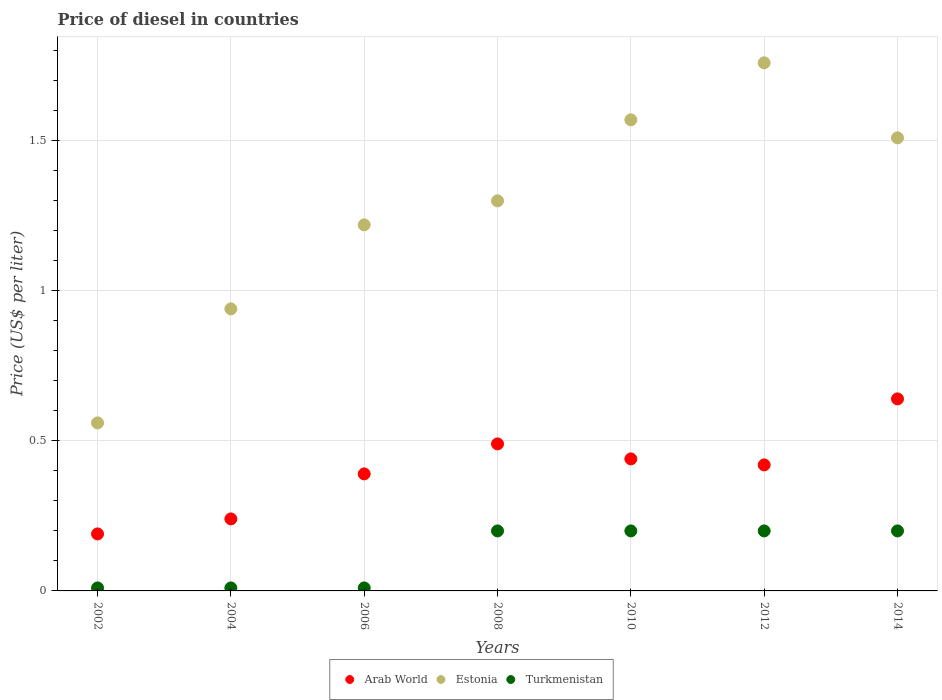Is the number of dotlines equal to the number of legend labels?
Your answer should be very brief. Yes. Across all years, what is the maximum price of diesel in Arab World?
Keep it short and to the point. 0.64. Across all years, what is the minimum price of diesel in Estonia?
Ensure brevity in your answer.  0.56. In which year was the price of diesel in Estonia maximum?
Give a very brief answer. 2012. What is the total price of diesel in Turkmenistan in the graph?
Keep it short and to the point. 0.83. What is the difference between the price of diesel in Estonia in 2004 and that in 2008?
Make the answer very short. -0.36. What is the difference between the price of diesel in Turkmenistan in 2004 and the price of diesel in Arab World in 2014?
Offer a very short reply. -0.63. What is the average price of diesel in Estonia per year?
Your response must be concise. 1.27. In the year 2010, what is the difference between the price of diesel in Estonia and price of diesel in Arab World?
Keep it short and to the point. 1.13. What is the ratio of the price of diesel in Estonia in 2002 to that in 2006?
Your answer should be very brief. 0.46. Is the price of diesel in Arab World in 2008 less than that in 2010?
Provide a short and direct response. No. Is the difference between the price of diesel in Estonia in 2006 and 2010 greater than the difference between the price of diesel in Arab World in 2006 and 2010?
Provide a succinct answer. No. What is the difference between the highest and the second highest price of diesel in Arab World?
Keep it short and to the point. 0.15. What is the difference between the highest and the lowest price of diesel in Turkmenistan?
Ensure brevity in your answer.  0.19. In how many years, is the price of diesel in Arab World greater than the average price of diesel in Arab World taken over all years?
Offer a very short reply. 4. Is the sum of the price of diesel in Turkmenistan in 2012 and 2014 greater than the maximum price of diesel in Estonia across all years?
Provide a succinct answer. No. Is it the case that in every year, the sum of the price of diesel in Arab World and price of diesel in Turkmenistan  is greater than the price of diesel in Estonia?
Your answer should be compact. No. Is the price of diesel in Estonia strictly less than the price of diesel in Arab World over the years?
Offer a very short reply. No. How many dotlines are there?
Offer a very short reply. 3. Does the graph contain any zero values?
Provide a succinct answer. No. What is the title of the graph?
Give a very brief answer. Price of diesel in countries. What is the label or title of the X-axis?
Your answer should be very brief. Years. What is the label or title of the Y-axis?
Provide a succinct answer. Price (US$ per liter). What is the Price (US$ per liter) of Arab World in 2002?
Make the answer very short. 0.19. What is the Price (US$ per liter) in Estonia in 2002?
Provide a short and direct response. 0.56. What is the Price (US$ per liter) in Arab World in 2004?
Provide a succinct answer. 0.24. What is the Price (US$ per liter) in Arab World in 2006?
Offer a very short reply. 0.39. What is the Price (US$ per liter) of Estonia in 2006?
Make the answer very short. 1.22. What is the Price (US$ per liter) of Turkmenistan in 2006?
Ensure brevity in your answer.  0.01. What is the Price (US$ per liter) in Arab World in 2008?
Provide a succinct answer. 0.49. What is the Price (US$ per liter) in Estonia in 2008?
Offer a terse response. 1.3. What is the Price (US$ per liter) in Arab World in 2010?
Your answer should be very brief. 0.44. What is the Price (US$ per liter) of Estonia in 2010?
Your answer should be compact. 1.57. What is the Price (US$ per liter) in Arab World in 2012?
Give a very brief answer. 0.42. What is the Price (US$ per liter) in Estonia in 2012?
Make the answer very short. 1.76. What is the Price (US$ per liter) of Arab World in 2014?
Provide a succinct answer. 0.64. What is the Price (US$ per liter) in Estonia in 2014?
Keep it short and to the point. 1.51. What is the Price (US$ per liter) in Turkmenistan in 2014?
Make the answer very short. 0.2. Across all years, what is the maximum Price (US$ per liter) in Arab World?
Provide a succinct answer. 0.64. Across all years, what is the maximum Price (US$ per liter) of Estonia?
Offer a very short reply. 1.76. Across all years, what is the minimum Price (US$ per liter) in Arab World?
Offer a terse response. 0.19. Across all years, what is the minimum Price (US$ per liter) of Estonia?
Your answer should be compact. 0.56. What is the total Price (US$ per liter) in Arab World in the graph?
Your response must be concise. 2.81. What is the total Price (US$ per liter) in Estonia in the graph?
Provide a short and direct response. 8.86. What is the total Price (US$ per liter) in Turkmenistan in the graph?
Give a very brief answer. 0.83. What is the difference between the Price (US$ per liter) of Arab World in 2002 and that in 2004?
Keep it short and to the point. -0.05. What is the difference between the Price (US$ per liter) of Estonia in 2002 and that in 2004?
Your response must be concise. -0.38. What is the difference between the Price (US$ per liter) in Estonia in 2002 and that in 2006?
Offer a terse response. -0.66. What is the difference between the Price (US$ per liter) in Turkmenistan in 2002 and that in 2006?
Provide a succinct answer. 0. What is the difference between the Price (US$ per liter) in Arab World in 2002 and that in 2008?
Offer a very short reply. -0.3. What is the difference between the Price (US$ per liter) in Estonia in 2002 and that in 2008?
Your answer should be very brief. -0.74. What is the difference between the Price (US$ per liter) of Turkmenistan in 2002 and that in 2008?
Keep it short and to the point. -0.19. What is the difference between the Price (US$ per liter) of Estonia in 2002 and that in 2010?
Keep it short and to the point. -1.01. What is the difference between the Price (US$ per liter) in Turkmenistan in 2002 and that in 2010?
Keep it short and to the point. -0.19. What is the difference between the Price (US$ per liter) in Arab World in 2002 and that in 2012?
Your answer should be very brief. -0.23. What is the difference between the Price (US$ per liter) of Estonia in 2002 and that in 2012?
Make the answer very short. -1.2. What is the difference between the Price (US$ per liter) of Turkmenistan in 2002 and that in 2012?
Offer a terse response. -0.19. What is the difference between the Price (US$ per liter) of Arab World in 2002 and that in 2014?
Offer a terse response. -0.45. What is the difference between the Price (US$ per liter) in Estonia in 2002 and that in 2014?
Make the answer very short. -0.95. What is the difference between the Price (US$ per liter) in Turkmenistan in 2002 and that in 2014?
Offer a terse response. -0.19. What is the difference between the Price (US$ per liter) of Arab World in 2004 and that in 2006?
Ensure brevity in your answer.  -0.15. What is the difference between the Price (US$ per liter) of Estonia in 2004 and that in 2006?
Make the answer very short. -0.28. What is the difference between the Price (US$ per liter) in Turkmenistan in 2004 and that in 2006?
Your response must be concise. 0. What is the difference between the Price (US$ per liter) in Arab World in 2004 and that in 2008?
Make the answer very short. -0.25. What is the difference between the Price (US$ per liter) in Estonia in 2004 and that in 2008?
Offer a terse response. -0.36. What is the difference between the Price (US$ per liter) of Turkmenistan in 2004 and that in 2008?
Keep it short and to the point. -0.19. What is the difference between the Price (US$ per liter) of Arab World in 2004 and that in 2010?
Your answer should be compact. -0.2. What is the difference between the Price (US$ per liter) of Estonia in 2004 and that in 2010?
Ensure brevity in your answer.  -0.63. What is the difference between the Price (US$ per liter) in Turkmenistan in 2004 and that in 2010?
Make the answer very short. -0.19. What is the difference between the Price (US$ per liter) of Arab World in 2004 and that in 2012?
Offer a very short reply. -0.18. What is the difference between the Price (US$ per liter) of Estonia in 2004 and that in 2012?
Keep it short and to the point. -0.82. What is the difference between the Price (US$ per liter) of Turkmenistan in 2004 and that in 2012?
Provide a short and direct response. -0.19. What is the difference between the Price (US$ per liter) in Arab World in 2004 and that in 2014?
Provide a succinct answer. -0.4. What is the difference between the Price (US$ per liter) in Estonia in 2004 and that in 2014?
Provide a succinct answer. -0.57. What is the difference between the Price (US$ per liter) in Turkmenistan in 2004 and that in 2014?
Give a very brief answer. -0.19. What is the difference between the Price (US$ per liter) in Estonia in 2006 and that in 2008?
Your answer should be very brief. -0.08. What is the difference between the Price (US$ per liter) in Turkmenistan in 2006 and that in 2008?
Give a very brief answer. -0.19. What is the difference between the Price (US$ per liter) in Estonia in 2006 and that in 2010?
Your response must be concise. -0.35. What is the difference between the Price (US$ per liter) of Turkmenistan in 2006 and that in 2010?
Give a very brief answer. -0.19. What is the difference between the Price (US$ per liter) in Arab World in 2006 and that in 2012?
Offer a terse response. -0.03. What is the difference between the Price (US$ per liter) of Estonia in 2006 and that in 2012?
Make the answer very short. -0.54. What is the difference between the Price (US$ per liter) in Turkmenistan in 2006 and that in 2012?
Ensure brevity in your answer.  -0.19. What is the difference between the Price (US$ per liter) in Arab World in 2006 and that in 2014?
Your answer should be compact. -0.25. What is the difference between the Price (US$ per liter) in Estonia in 2006 and that in 2014?
Your answer should be compact. -0.29. What is the difference between the Price (US$ per liter) in Turkmenistan in 2006 and that in 2014?
Your response must be concise. -0.19. What is the difference between the Price (US$ per liter) in Arab World in 2008 and that in 2010?
Offer a very short reply. 0.05. What is the difference between the Price (US$ per liter) in Estonia in 2008 and that in 2010?
Offer a terse response. -0.27. What is the difference between the Price (US$ per liter) of Turkmenistan in 2008 and that in 2010?
Give a very brief answer. 0. What is the difference between the Price (US$ per liter) in Arab World in 2008 and that in 2012?
Ensure brevity in your answer.  0.07. What is the difference between the Price (US$ per liter) of Estonia in 2008 and that in 2012?
Offer a very short reply. -0.46. What is the difference between the Price (US$ per liter) in Arab World in 2008 and that in 2014?
Offer a terse response. -0.15. What is the difference between the Price (US$ per liter) of Estonia in 2008 and that in 2014?
Ensure brevity in your answer.  -0.21. What is the difference between the Price (US$ per liter) of Turkmenistan in 2008 and that in 2014?
Give a very brief answer. 0. What is the difference between the Price (US$ per liter) of Arab World in 2010 and that in 2012?
Offer a very short reply. 0.02. What is the difference between the Price (US$ per liter) in Estonia in 2010 and that in 2012?
Your answer should be compact. -0.19. What is the difference between the Price (US$ per liter) in Turkmenistan in 2010 and that in 2012?
Provide a succinct answer. 0. What is the difference between the Price (US$ per liter) in Arab World in 2010 and that in 2014?
Keep it short and to the point. -0.2. What is the difference between the Price (US$ per liter) of Turkmenistan in 2010 and that in 2014?
Your answer should be very brief. 0. What is the difference between the Price (US$ per liter) of Arab World in 2012 and that in 2014?
Offer a terse response. -0.22. What is the difference between the Price (US$ per liter) of Arab World in 2002 and the Price (US$ per liter) of Estonia in 2004?
Keep it short and to the point. -0.75. What is the difference between the Price (US$ per liter) of Arab World in 2002 and the Price (US$ per liter) of Turkmenistan in 2004?
Offer a very short reply. 0.18. What is the difference between the Price (US$ per liter) in Estonia in 2002 and the Price (US$ per liter) in Turkmenistan in 2004?
Keep it short and to the point. 0.55. What is the difference between the Price (US$ per liter) of Arab World in 2002 and the Price (US$ per liter) of Estonia in 2006?
Make the answer very short. -1.03. What is the difference between the Price (US$ per liter) in Arab World in 2002 and the Price (US$ per liter) in Turkmenistan in 2006?
Your answer should be compact. 0.18. What is the difference between the Price (US$ per liter) in Estonia in 2002 and the Price (US$ per liter) in Turkmenistan in 2006?
Your answer should be very brief. 0.55. What is the difference between the Price (US$ per liter) in Arab World in 2002 and the Price (US$ per liter) in Estonia in 2008?
Your answer should be compact. -1.11. What is the difference between the Price (US$ per liter) in Arab World in 2002 and the Price (US$ per liter) in Turkmenistan in 2008?
Keep it short and to the point. -0.01. What is the difference between the Price (US$ per liter) of Estonia in 2002 and the Price (US$ per liter) of Turkmenistan in 2008?
Give a very brief answer. 0.36. What is the difference between the Price (US$ per liter) of Arab World in 2002 and the Price (US$ per liter) of Estonia in 2010?
Your answer should be compact. -1.38. What is the difference between the Price (US$ per liter) of Arab World in 2002 and the Price (US$ per liter) of Turkmenistan in 2010?
Your response must be concise. -0.01. What is the difference between the Price (US$ per liter) of Estonia in 2002 and the Price (US$ per liter) of Turkmenistan in 2010?
Keep it short and to the point. 0.36. What is the difference between the Price (US$ per liter) in Arab World in 2002 and the Price (US$ per liter) in Estonia in 2012?
Give a very brief answer. -1.57. What is the difference between the Price (US$ per liter) of Arab World in 2002 and the Price (US$ per liter) of Turkmenistan in 2012?
Ensure brevity in your answer.  -0.01. What is the difference between the Price (US$ per liter) in Estonia in 2002 and the Price (US$ per liter) in Turkmenistan in 2012?
Your answer should be very brief. 0.36. What is the difference between the Price (US$ per liter) of Arab World in 2002 and the Price (US$ per liter) of Estonia in 2014?
Make the answer very short. -1.32. What is the difference between the Price (US$ per liter) of Arab World in 2002 and the Price (US$ per liter) of Turkmenistan in 2014?
Your response must be concise. -0.01. What is the difference between the Price (US$ per liter) of Estonia in 2002 and the Price (US$ per liter) of Turkmenistan in 2014?
Give a very brief answer. 0.36. What is the difference between the Price (US$ per liter) in Arab World in 2004 and the Price (US$ per liter) in Estonia in 2006?
Provide a short and direct response. -0.98. What is the difference between the Price (US$ per liter) in Arab World in 2004 and the Price (US$ per liter) in Turkmenistan in 2006?
Your answer should be very brief. 0.23. What is the difference between the Price (US$ per liter) in Arab World in 2004 and the Price (US$ per liter) in Estonia in 2008?
Your answer should be compact. -1.06. What is the difference between the Price (US$ per liter) in Estonia in 2004 and the Price (US$ per liter) in Turkmenistan in 2008?
Offer a very short reply. 0.74. What is the difference between the Price (US$ per liter) in Arab World in 2004 and the Price (US$ per liter) in Estonia in 2010?
Keep it short and to the point. -1.33. What is the difference between the Price (US$ per liter) of Arab World in 2004 and the Price (US$ per liter) of Turkmenistan in 2010?
Your answer should be compact. 0.04. What is the difference between the Price (US$ per liter) in Estonia in 2004 and the Price (US$ per liter) in Turkmenistan in 2010?
Your answer should be very brief. 0.74. What is the difference between the Price (US$ per liter) in Arab World in 2004 and the Price (US$ per liter) in Estonia in 2012?
Ensure brevity in your answer.  -1.52. What is the difference between the Price (US$ per liter) in Estonia in 2004 and the Price (US$ per liter) in Turkmenistan in 2012?
Provide a succinct answer. 0.74. What is the difference between the Price (US$ per liter) of Arab World in 2004 and the Price (US$ per liter) of Estonia in 2014?
Your answer should be very brief. -1.27. What is the difference between the Price (US$ per liter) of Estonia in 2004 and the Price (US$ per liter) of Turkmenistan in 2014?
Your answer should be very brief. 0.74. What is the difference between the Price (US$ per liter) in Arab World in 2006 and the Price (US$ per liter) in Estonia in 2008?
Provide a succinct answer. -0.91. What is the difference between the Price (US$ per liter) of Arab World in 2006 and the Price (US$ per liter) of Turkmenistan in 2008?
Give a very brief answer. 0.19. What is the difference between the Price (US$ per liter) of Estonia in 2006 and the Price (US$ per liter) of Turkmenistan in 2008?
Your answer should be very brief. 1.02. What is the difference between the Price (US$ per liter) of Arab World in 2006 and the Price (US$ per liter) of Estonia in 2010?
Make the answer very short. -1.18. What is the difference between the Price (US$ per liter) of Arab World in 2006 and the Price (US$ per liter) of Turkmenistan in 2010?
Offer a very short reply. 0.19. What is the difference between the Price (US$ per liter) in Estonia in 2006 and the Price (US$ per liter) in Turkmenistan in 2010?
Make the answer very short. 1.02. What is the difference between the Price (US$ per liter) of Arab World in 2006 and the Price (US$ per liter) of Estonia in 2012?
Your answer should be very brief. -1.37. What is the difference between the Price (US$ per liter) in Arab World in 2006 and the Price (US$ per liter) in Turkmenistan in 2012?
Provide a short and direct response. 0.19. What is the difference between the Price (US$ per liter) in Arab World in 2006 and the Price (US$ per liter) in Estonia in 2014?
Keep it short and to the point. -1.12. What is the difference between the Price (US$ per liter) in Arab World in 2006 and the Price (US$ per liter) in Turkmenistan in 2014?
Give a very brief answer. 0.19. What is the difference between the Price (US$ per liter) of Arab World in 2008 and the Price (US$ per liter) of Estonia in 2010?
Provide a succinct answer. -1.08. What is the difference between the Price (US$ per liter) in Arab World in 2008 and the Price (US$ per liter) in Turkmenistan in 2010?
Keep it short and to the point. 0.29. What is the difference between the Price (US$ per liter) of Arab World in 2008 and the Price (US$ per liter) of Estonia in 2012?
Provide a succinct answer. -1.27. What is the difference between the Price (US$ per liter) in Arab World in 2008 and the Price (US$ per liter) in Turkmenistan in 2012?
Your answer should be compact. 0.29. What is the difference between the Price (US$ per liter) in Estonia in 2008 and the Price (US$ per liter) in Turkmenistan in 2012?
Provide a succinct answer. 1.1. What is the difference between the Price (US$ per liter) in Arab World in 2008 and the Price (US$ per liter) in Estonia in 2014?
Provide a succinct answer. -1.02. What is the difference between the Price (US$ per liter) in Arab World in 2008 and the Price (US$ per liter) in Turkmenistan in 2014?
Your response must be concise. 0.29. What is the difference between the Price (US$ per liter) in Estonia in 2008 and the Price (US$ per liter) in Turkmenistan in 2014?
Ensure brevity in your answer.  1.1. What is the difference between the Price (US$ per liter) in Arab World in 2010 and the Price (US$ per liter) in Estonia in 2012?
Your response must be concise. -1.32. What is the difference between the Price (US$ per liter) of Arab World in 2010 and the Price (US$ per liter) of Turkmenistan in 2012?
Provide a short and direct response. 0.24. What is the difference between the Price (US$ per liter) in Estonia in 2010 and the Price (US$ per liter) in Turkmenistan in 2012?
Offer a terse response. 1.37. What is the difference between the Price (US$ per liter) of Arab World in 2010 and the Price (US$ per liter) of Estonia in 2014?
Provide a succinct answer. -1.07. What is the difference between the Price (US$ per liter) of Arab World in 2010 and the Price (US$ per liter) of Turkmenistan in 2014?
Keep it short and to the point. 0.24. What is the difference between the Price (US$ per liter) of Estonia in 2010 and the Price (US$ per liter) of Turkmenistan in 2014?
Provide a short and direct response. 1.37. What is the difference between the Price (US$ per liter) of Arab World in 2012 and the Price (US$ per liter) of Estonia in 2014?
Make the answer very short. -1.09. What is the difference between the Price (US$ per liter) of Arab World in 2012 and the Price (US$ per liter) of Turkmenistan in 2014?
Offer a very short reply. 0.22. What is the difference between the Price (US$ per liter) in Estonia in 2012 and the Price (US$ per liter) in Turkmenistan in 2014?
Provide a succinct answer. 1.56. What is the average Price (US$ per liter) in Arab World per year?
Provide a succinct answer. 0.4. What is the average Price (US$ per liter) of Estonia per year?
Provide a succinct answer. 1.27. What is the average Price (US$ per liter) in Turkmenistan per year?
Your response must be concise. 0.12. In the year 2002, what is the difference between the Price (US$ per liter) of Arab World and Price (US$ per liter) of Estonia?
Ensure brevity in your answer.  -0.37. In the year 2002, what is the difference between the Price (US$ per liter) of Arab World and Price (US$ per liter) of Turkmenistan?
Your response must be concise. 0.18. In the year 2002, what is the difference between the Price (US$ per liter) in Estonia and Price (US$ per liter) in Turkmenistan?
Your answer should be compact. 0.55. In the year 2004, what is the difference between the Price (US$ per liter) of Arab World and Price (US$ per liter) of Estonia?
Your response must be concise. -0.7. In the year 2004, what is the difference between the Price (US$ per liter) of Arab World and Price (US$ per liter) of Turkmenistan?
Give a very brief answer. 0.23. In the year 2004, what is the difference between the Price (US$ per liter) of Estonia and Price (US$ per liter) of Turkmenistan?
Ensure brevity in your answer.  0.93. In the year 2006, what is the difference between the Price (US$ per liter) in Arab World and Price (US$ per liter) in Estonia?
Provide a succinct answer. -0.83. In the year 2006, what is the difference between the Price (US$ per liter) of Arab World and Price (US$ per liter) of Turkmenistan?
Give a very brief answer. 0.38. In the year 2006, what is the difference between the Price (US$ per liter) of Estonia and Price (US$ per liter) of Turkmenistan?
Keep it short and to the point. 1.21. In the year 2008, what is the difference between the Price (US$ per liter) in Arab World and Price (US$ per liter) in Estonia?
Make the answer very short. -0.81. In the year 2008, what is the difference between the Price (US$ per liter) in Arab World and Price (US$ per liter) in Turkmenistan?
Your response must be concise. 0.29. In the year 2008, what is the difference between the Price (US$ per liter) of Estonia and Price (US$ per liter) of Turkmenistan?
Your answer should be compact. 1.1. In the year 2010, what is the difference between the Price (US$ per liter) in Arab World and Price (US$ per liter) in Estonia?
Offer a terse response. -1.13. In the year 2010, what is the difference between the Price (US$ per liter) in Arab World and Price (US$ per liter) in Turkmenistan?
Your answer should be compact. 0.24. In the year 2010, what is the difference between the Price (US$ per liter) of Estonia and Price (US$ per liter) of Turkmenistan?
Your answer should be compact. 1.37. In the year 2012, what is the difference between the Price (US$ per liter) of Arab World and Price (US$ per liter) of Estonia?
Ensure brevity in your answer.  -1.34. In the year 2012, what is the difference between the Price (US$ per liter) of Arab World and Price (US$ per liter) of Turkmenistan?
Your response must be concise. 0.22. In the year 2012, what is the difference between the Price (US$ per liter) of Estonia and Price (US$ per liter) of Turkmenistan?
Your answer should be very brief. 1.56. In the year 2014, what is the difference between the Price (US$ per liter) in Arab World and Price (US$ per liter) in Estonia?
Your answer should be compact. -0.87. In the year 2014, what is the difference between the Price (US$ per liter) of Arab World and Price (US$ per liter) of Turkmenistan?
Ensure brevity in your answer.  0.44. In the year 2014, what is the difference between the Price (US$ per liter) in Estonia and Price (US$ per liter) in Turkmenistan?
Offer a terse response. 1.31. What is the ratio of the Price (US$ per liter) in Arab World in 2002 to that in 2004?
Offer a very short reply. 0.79. What is the ratio of the Price (US$ per liter) of Estonia in 2002 to that in 2004?
Provide a succinct answer. 0.6. What is the ratio of the Price (US$ per liter) in Arab World in 2002 to that in 2006?
Your response must be concise. 0.49. What is the ratio of the Price (US$ per liter) of Estonia in 2002 to that in 2006?
Your response must be concise. 0.46. What is the ratio of the Price (US$ per liter) of Turkmenistan in 2002 to that in 2006?
Your answer should be compact. 1. What is the ratio of the Price (US$ per liter) in Arab World in 2002 to that in 2008?
Provide a succinct answer. 0.39. What is the ratio of the Price (US$ per liter) in Estonia in 2002 to that in 2008?
Provide a short and direct response. 0.43. What is the ratio of the Price (US$ per liter) in Arab World in 2002 to that in 2010?
Provide a short and direct response. 0.43. What is the ratio of the Price (US$ per liter) in Estonia in 2002 to that in 2010?
Your answer should be compact. 0.36. What is the ratio of the Price (US$ per liter) of Turkmenistan in 2002 to that in 2010?
Offer a very short reply. 0.05. What is the ratio of the Price (US$ per liter) in Arab World in 2002 to that in 2012?
Offer a very short reply. 0.45. What is the ratio of the Price (US$ per liter) of Estonia in 2002 to that in 2012?
Your response must be concise. 0.32. What is the ratio of the Price (US$ per liter) in Arab World in 2002 to that in 2014?
Provide a succinct answer. 0.3. What is the ratio of the Price (US$ per liter) in Estonia in 2002 to that in 2014?
Offer a very short reply. 0.37. What is the ratio of the Price (US$ per liter) in Arab World in 2004 to that in 2006?
Ensure brevity in your answer.  0.62. What is the ratio of the Price (US$ per liter) in Estonia in 2004 to that in 2006?
Your response must be concise. 0.77. What is the ratio of the Price (US$ per liter) of Arab World in 2004 to that in 2008?
Keep it short and to the point. 0.49. What is the ratio of the Price (US$ per liter) in Estonia in 2004 to that in 2008?
Your answer should be compact. 0.72. What is the ratio of the Price (US$ per liter) of Turkmenistan in 2004 to that in 2008?
Offer a terse response. 0.05. What is the ratio of the Price (US$ per liter) in Arab World in 2004 to that in 2010?
Your answer should be very brief. 0.55. What is the ratio of the Price (US$ per liter) of Estonia in 2004 to that in 2010?
Your answer should be compact. 0.6. What is the ratio of the Price (US$ per liter) of Turkmenistan in 2004 to that in 2010?
Provide a short and direct response. 0.05. What is the ratio of the Price (US$ per liter) in Estonia in 2004 to that in 2012?
Your answer should be compact. 0.53. What is the ratio of the Price (US$ per liter) of Turkmenistan in 2004 to that in 2012?
Your answer should be very brief. 0.05. What is the ratio of the Price (US$ per liter) in Estonia in 2004 to that in 2014?
Keep it short and to the point. 0.62. What is the ratio of the Price (US$ per liter) of Turkmenistan in 2004 to that in 2014?
Offer a terse response. 0.05. What is the ratio of the Price (US$ per liter) of Arab World in 2006 to that in 2008?
Provide a short and direct response. 0.8. What is the ratio of the Price (US$ per liter) in Estonia in 2006 to that in 2008?
Give a very brief answer. 0.94. What is the ratio of the Price (US$ per liter) of Turkmenistan in 2006 to that in 2008?
Give a very brief answer. 0.05. What is the ratio of the Price (US$ per liter) of Arab World in 2006 to that in 2010?
Your answer should be very brief. 0.89. What is the ratio of the Price (US$ per liter) in Estonia in 2006 to that in 2010?
Your answer should be compact. 0.78. What is the ratio of the Price (US$ per liter) of Turkmenistan in 2006 to that in 2010?
Your response must be concise. 0.05. What is the ratio of the Price (US$ per liter) of Estonia in 2006 to that in 2012?
Make the answer very short. 0.69. What is the ratio of the Price (US$ per liter) in Turkmenistan in 2006 to that in 2012?
Give a very brief answer. 0.05. What is the ratio of the Price (US$ per liter) of Arab World in 2006 to that in 2014?
Provide a short and direct response. 0.61. What is the ratio of the Price (US$ per liter) in Estonia in 2006 to that in 2014?
Make the answer very short. 0.81. What is the ratio of the Price (US$ per liter) in Turkmenistan in 2006 to that in 2014?
Ensure brevity in your answer.  0.05. What is the ratio of the Price (US$ per liter) of Arab World in 2008 to that in 2010?
Offer a very short reply. 1.11. What is the ratio of the Price (US$ per liter) in Estonia in 2008 to that in 2010?
Your answer should be very brief. 0.83. What is the ratio of the Price (US$ per liter) of Turkmenistan in 2008 to that in 2010?
Your response must be concise. 1. What is the ratio of the Price (US$ per liter) in Arab World in 2008 to that in 2012?
Your response must be concise. 1.17. What is the ratio of the Price (US$ per liter) in Estonia in 2008 to that in 2012?
Ensure brevity in your answer.  0.74. What is the ratio of the Price (US$ per liter) in Arab World in 2008 to that in 2014?
Your response must be concise. 0.77. What is the ratio of the Price (US$ per liter) of Estonia in 2008 to that in 2014?
Ensure brevity in your answer.  0.86. What is the ratio of the Price (US$ per liter) of Arab World in 2010 to that in 2012?
Give a very brief answer. 1.05. What is the ratio of the Price (US$ per liter) in Estonia in 2010 to that in 2012?
Your response must be concise. 0.89. What is the ratio of the Price (US$ per liter) of Arab World in 2010 to that in 2014?
Offer a terse response. 0.69. What is the ratio of the Price (US$ per liter) of Estonia in 2010 to that in 2014?
Offer a very short reply. 1.04. What is the ratio of the Price (US$ per liter) in Turkmenistan in 2010 to that in 2014?
Give a very brief answer. 1. What is the ratio of the Price (US$ per liter) in Arab World in 2012 to that in 2014?
Give a very brief answer. 0.66. What is the ratio of the Price (US$ per liter) in Estonia in 2012 to that in 2014?
Keep it short and to the point. 1.17. What is the difference between the highest and the second highest Price (US$ per liter) of Arab World?
Your response must be concise. 0.15. What is the difference between the highest and the second highest Price (US$ per liter) of Estonia?
Give a very brief answer. 0.19. What is the difference between the highest and the lowest Price (US$ per liter) of Arab World?
Provide a succinct answer. 0.45. What is the difference between the highest and the lowest Price (US$ per liter) in Estonia?
Offer a terse response. 1.2. What is the difference between the highest and the lowest Price (US$ per liter) of Turkmenistan?
Give a very brief answer. 0.19. 